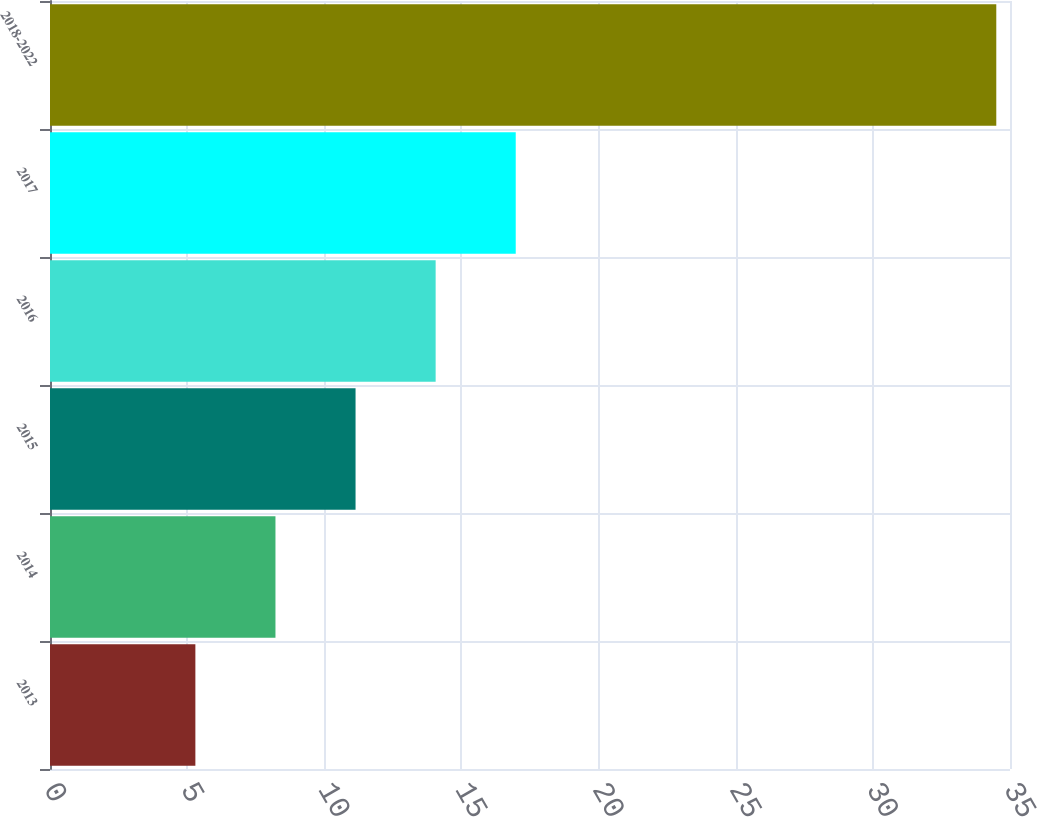Convert chart. <chart><loc_0><loc_0><loc_500><loc_500><bar_chart><fcel>2013<fcel>2014<fcel>2015<fcel>2016<fcel>2017<fcel>2018-2022<nl><fcel>5.3<fcel>8.22<fcel>11.14<fcel>14.06<fcel>16.98<fcel>34.5<nl></chart> 